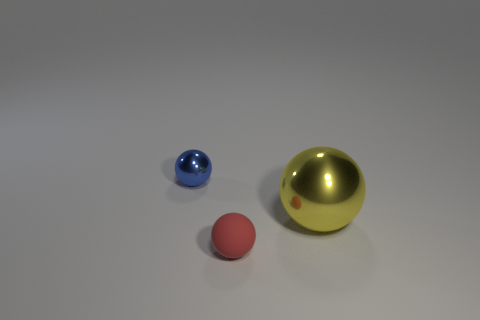Add 1 tiny red spheres. How many objects exist? 4 Subtract 0 purple spheres. How many objects are left? 3 Subtract all small shiny balls. Subtract all blue shiny cylinders. How many objects are left? 2 Add 1 small blue metal things. How many small blue metal things are left? 2 Add 1 yellow objects. How many yellow objects exist? 2 